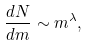Convert formula to latex. <formula><loc_0><loc_0><loc_500><loc_500>\frac { d N } { d m } \sim m ^ { \lambda } ,</formula> 